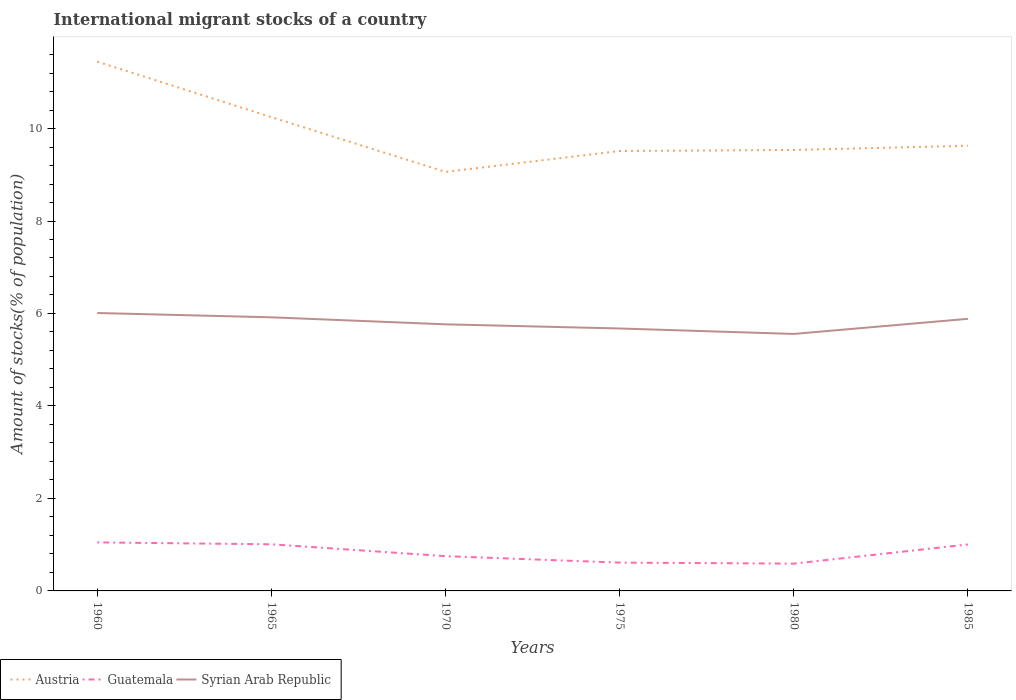Does the line corresponding to Guatemala intersect with the line corresponding to Austria?
Give a very brief answer. No. Is the number of lines equal to the number of legend labels?
Provide a succinct answer. Yes. Across all years, what is the maximum amount of stocks in in Austria?
Your answer should be very brief. 9.06. In which year was the amount of stocks in in Guatemala maximum?
Offer a terse response. 1980. What is the total amount of stocks in in Guatemala in the graph?
Make the answer very short. 0.16. What is the difference between the highest and the second highest amount of stocks in in Syrian Arab Republic?
Your answer should be very brief. 0.45. What is the difference between the highest and the lowest amount of stocks in in Guatemala?
Your answer should be very brief. 3. How many lines are there?
Offer a very short reply. 3. What is the title of the graph?
Give a very brief answer. International migrant stocks of a country. Does "Greenland" appear as one of the legend labels in the graph?
Ensure brevity in your answer.  No. What is the label or title of the X-axis?
Offer a terse response. Years. What is the label or title of the Y-axis?
Ensure brevity in your answer.  Amount of stocks(% of population). What is the Amount of stocks(% of population) in Austria in 1960?
Make the answer very short. 11.45. What is the Amount of stocks(% of population) in Guatemala in 1960?
Offer a very short reply. 1.05. What is the Amount of stocks(% of population) of Syrian Arab Republic in 1960?
Offer a very short reply. 6.01. What is the Amount of stocks(% of population) of Austria in 1965?
Your answer should be compact. 10.25. What is the Amount of stocks(% of population) in Guatemala in 1965?
Offer a terse response. 1.01. What is the Amount of stocks(% of population) in Syrian Arab Republic in 1965?
Keep it short and to the point. 5.92. What is the Amount of stocks(% of population) in Austria in 1970?
Give a very brief answer. 9.06. What is the Amount of stocks(% of population) of Guatemala in 1970?
Your answer should be very brief. 0.75. What is the Amount of stocks(% of population) in Syrian Arab Republic in 1970?
Your answer should be very brief. 5.77. What is the Amount of stocks(% of population) of Austria in 1975?
Your answer should be very brief. 9.51. What is the Amount of stocks(% of population) of Guatemala in 1975?
Give a very brief answer. 0.61. What is the Amount of stocks(% of population) of Syrian Arab Republic in 1975?
Offer a terse response. 5.68. What is the Amount of stocks(% of population) of Austria in 1980?
Give a very brief answer. 9.54. What is the Amount of stocks(% of population) in Guatemala in 1980?
Your answer should be very brief. 0.59. What is the Amount of stocks(% of population) in Syrian Arab Republic in 1980?
Provide a short and direct response. 5.56. What is the Amount of stocks(% of population) of Austria in 1985?
Provide a succinct answer. 9.63. What is the Amount of stocks(% of population) of Guatemala in 1985?
Ensure brevity in your answer.  1.01. What is the Amount of stocks(% of population) in Syrian Arab Republic in 1985?
Make the answer very short. 5.88. Across all years, what is the maximum Amount of stocks(% of population) of Austria?
Provide a short and direct response. 11.45. Across all years, what is the maximum Amount of stocks(% of population) in Guatemala?
Your answer should be very brief. 1.05. Across all years, what is the maximum Amount of stocks(% of population) of Syrian Arab Republic?
Provide a short and direct response. 6.01. Across all years, what is the minimum Amount of stocks(% of population) of Austria?
Your answer should be very brief. 9.06. Across all years, what is the minimum Amount of stocks(% of population) of Guatemala?
Your response must be concise. 0.59. Across all years, what is the minimum Amount of stocks(% of population) of Syrian Arab Republic?
Give a very brief answer. 5.56. What is the total Amount of stocks(% of population) in Austria in the graph?
Give a very brief answer. 59.43. What is the total Amount of stocks(% of population) of Guatemala in the graph?
Ensure brevity in your answer.  5.02. What is the total Amount of stocks(% of population) of Syrian Arab Republic in the graph?
Keep it short and to the point. 34.81. What is the difference between the Amount of stocks(% of population) of Austria in 1960 and that in 1965?
Offer a very short reply. 1.2. What is the difference between the Amount of stocks(% of population) of Guatemala in 1960 and that in 1965?
Keep it short and to the point. 0.04. What is the difference between the Amount of stocks(% of population) of Syrian Arab Republic in 1960 and that in 1965?
Your answer should be compact. 0.09. What is the difference between the Amount of stocks(% of population) of Austria in 1960 and that in 1970?
Make the answer very short. 2.38. What is the difference between the Amount of stocks(% of population) in Guatemala in 1960 and that in 1970?
Make the answer very short. 0.3. What is the difference between the Amount of stocks(% of population) of Syrian Arab Republic in 1960 and that in 1970?
Give a very brief answer. 0.25. What is the difference between the Amount of stocks(% of population) in Austria in 1960 and that in 1975?
Give a very brief answer. 1.93. What is the difference between the Amount of stocks(% of population) in Guatemala in 1960 and that in 1975?
Provide a short and direct response. 0.44. What is the difference between the Amount of stocks(% of population) of Syrian Arab Republic in 1960 and that in 1975?
Offer a terse response. 0.34. What is the difference between the Amount of stocks(% of population) of Austria in 1960 and that in 1980?
Offer a terse response. 1.91. What is the difference between the Amount of stocks(% of population) of Guatemala in 1960 and that in 1980?
Make the answer very short. 0.46. What is the difference between the Amount of stocks(% of population) in Syrian Arab Republic in 1960 and that in 1980?
Give a very brief answer. 0.45. What is the difference between the Amount of stocks(% of population) in Austria in 1960 and that in 1985?
Offer a terse response. 1.82. What is the difference between the Amount of stocks(% of population) in Guatemala in 1960 and that in 1985?
Your answer should be compact. 0.04. What is the difference between the Amount of stocks(% of population) of Syrian Arab Republic in 1960 and that in 1985?
Offer a very short reply. 0.13. What is the difference between the Amount of stocks(% of population) in Austria in 1965 and that in 1970?
Give a very brief answer. 1.18. What is the difference between the Amount of stocks(% of population) in Guatemala in 1965 and that in 1970?
Offer a terse response. 0.26. What is the difference between the Amount of stocks(% of population) in Syrian Arab Republic in 1965 and that in 1970?
Keep it short and to the point. 0.15. What is the difference between the Amount of stocks(% of population) in Austria in 1965 and that in 1975?
Offer a terse response. 0.73. What is the difference between the Amount of stocks(% of population) of Guatemala in 1965 and that in 1975?
Your answer should be very brief. 0.4. What is the difference between the Amount of stocks(% of population) of Syrian Arab Republic in 1965 and that in 1975?
Offer a terse response. 0.24. What is the difference between the Amount of stocks(% of population) of Austria in 1965 and that in 1980?
Your response must be concise. 0.71. What is the difference between the Amount of stocks(% of population) in Guatemala in 1965 and that in 1980?
Provide a short and direct response. 0.42. What is the difference between the Amount of stocks(% of population) of Syrian Arab Republic in 1965 and that in 1980?
Give a very brief answer. 0.36. What is the difference between the Amount of stocks(% of population) of Austria in 1965 and that in 1985?
Offer a very short reply. 0.62. What is the difference between the Amount of stocks(% of population) in Guatemala in 1965 and that in 1985?
Give a very brief answer. 0. What is the difference between the Amount of stocks(% of population) of Syrian Arab Republic in 1965 and that in 1985?
Offer a terse response. 0.03. What is the difference between the Amount of stocks(% of population) of Austria in 1970 and that in 1975?
Give a very brief answer. -0.45. What is the difference between the Amount of stocks(% of population) in Guatemala in 1970 and that in 1975?
Your response must be concise. 0.14. What is the difference between the Amount of stocks(% of population) in Syrian Arab Republic in 1970 and that in 1975?
Give a very brief answer. 0.09. What is the difference between the Amount of stocks(% of population) in Austria in 1970 and that in 1980?
Offer a very short reply. -0.47. What is the difference between the Amount of stocks(% of population) of Guatemala in 1970 and that in 1980?
Provide a short and direct response. 0.16. What is the difference between the Amount of stocks(% of population) in Syrian Arab Republic in 1970 and that in 1980?
Your answer should be very brief. 0.21. What is the difference between the Amount of stocks(% of population) in Austria in 1970 and that in 1985?
Ensure brevity in your answer.  -0.57. What is the difference between the Amount of stocks(% of population) of Guatemala in 1970 and that in 1985?
Provide a short and direct response. -0.25. What is the difference between the Amount of stocks(% of population) in Syrian Arab Republic in 1970 and that in 1985?
Your answer should be compact. -0.12. What is the difference between the Amount of stocks(% of population) in Austria in 1975 and that in 1980?
Make the answer very short. -0.02. What is the difference between the Amount of stocks(% of population) in Guatemala in 1975 and that in 1980?
Provide a short and direct response. 0.02. What is the difference between the Amount of stocks(% of population) of Syrian Arab Republic in 1975 and that in 1980?
Keep it short and to the point. 0.12. What is the difference between the Amount of stocks(% of population) of Austria in 1975 and that in 1985?
Provide a succinct answer. -0.11. What is the difference between the Amount of stocks(% of population) of Guatemala in 1975 and that in 1985?
Keep it short and to the point. -0.39. What is the difference between the Amount of stocks(% of population) of Syrian Arab Republic in 1975 and that in 1985?
Offer a terse response. -0.21. What is the difference between the Amount of stocks(% of population) of Austria in 1980 and that in 1985?
Your answer should be compact. -0.09. What is the difference between the Amount of stocks(% of population) in Guatemala in 1980 and that in 1985?
Provide a succinct answer. -0.41. What is the difference between the Amount of stocks(% of population) in Syrian Arab Republic in 1980 and that in 1985?
Keep it short and to the point. -0.33. What is the difference between the Amount of stocks(% of population) in Austria in 1960 and the Amount of stocks(% of population) in Guatemala in 1965?
Your answer should be compact. 10.44. What is the difference between the Amount of stocks(% of population) in Austria in 1960 and the Amount of stocks(% of population) in Syrian Arab Republic in 1965?
Offer a terse response. 5.53. What is the difference between the Amount of stocks(% of population) in Guatemala in 1960 and the Amount of stocks(% of population) in Syrian Arab Republic in 1965?
Keep it short and to the point. -4.87. What is the difference between the Amount of stocks(% of population) of Austria in 1960 and the Amount of stocks(% of population) of Guatemala in 1970?
Keep it short and to the point. 10.69. What is the difference between the Amount of stocks(% of population) of Austria in 1960 and the Amount of stocks(% of population) of Syrian Arab Republic in 1970?
Your answer should be compact. 5.68. What is the difference between the Amount of stocks(% of population) of Guatemala in 1960 and the Amount of stocks(% of population) of Syrian Arab Republic in 1970?
Offer a very short reply. -4.72. What is the difference between the Amount of stocks(% of population) in Austria in 1960 and the Amount of stocks(% of population) in Guatemala in 1975?
Make the answer very short. 10.83. What is the difference between the Amount of stocks(% of population) in Austria in 1960 and the Amount of stocks(% of population) in Syrian Arab Republic in 1975?
Give a very brief answer. 5.77. What is the difference between the Amount of stocks(% of population) of Guatemala in 1960 and the Amount of stocks(% of population) of Syrian Arab Republic in 1975?
Offer a very short reply. -4.63. What is the difference between the Amount of stocks(% of population) in Austria in 1960 and the Amount of stocks(% of population) in Guatemala in 1980?
Provide a short and direct response. 10.86. What is the difference between the Amount of stocks(% of population) of Austria in 1960 and the Amount of stocks(% of population) of Syrian Arab Republic in 1980?
Give a very brief answer. 5.89. What is the difference between the Amount of stocks(% of population) of Guatemala in 1960 and the Amount of stocks(% of population) of Syrian Arab Republic in 1980?
Offer a terse response. -4.51. What is the difference between the Amount of stocks(% of population) in Austria in 1960 and the Amount of stocks(% of population) in Guatemala in 1985?
Ensure brevity in your answer.  10.44. What is the difference between the Amount of stocks(% of population) of Austria in 1960 and the Amount of stocks(% of population) of Syrian Arab Republic in 1985?
Ensure brevity in your answer.  5.56. What is the difference between the Amount of stocks(% of population) of Guatemala in 1960 and the Amount of stocks(% of population) of Syrian Arab Republic in 1985?
Offer a terse response. -4.84. What is the difference between the Amount of stocks(% of population) of Austria in 1965 and the Amount of stocks(% of population) of Guatemala in 1970?
Your response must be concise. 9.49. What is the difference between the Amount of stocks(% of population) of Austria in 1965 and the Amount of stocks(% of population) of Syrian Arab Republic in 1970?
Make the answer very short. 4.48. What is the difference between the Amount of stocks(% of population) in Guatemala in 1965 and the Amount of stocks(% of population) in Syrian Arab Republic in 1970?
Give a very brief answer. -4.76. What is the difference between the Amount of stocks(% of population) of Austria in 1965 and the Amount of stocks(% of population) of Guatemala in 1975?
Provide a short and direct response. 9.63. What is the difference between the Amount of stocks(% of population) in Austria in 1965 and the Amount of stocks(% of population) in Syrian Arab Republic in 1975?
Make the answer very short. 4.57. What is the difference between the Amount of stocks(% of population) in Guatemala in 1965 and the Amount of stocks(% of population) in Syrian Arab Republic in 1975?
Make the answer very short. -4.67. What is the difference between the Amount of stocks(% of population) of Austria in 1965 and the Amount of stocks(% of population) of Guatemala in 1980?
Keep it short and to the point. 9.66. What is the difference between the Amount of stocks(% of population) of Austria in 1965 and the Amount of stocks(% of population) of Syrian Arab Republic in 1980?
Give a very brief answer. 4.69. What is the difference between the Amount of stocks(% of population) of Guatemala in 1965 and the Amount of stocks(% of population) of Syrian Arab Republic in 1980?
Offer a terse response. -4.55. What is the difference between the Amount of stocks(% of population) of Austria in 1965 and the Amount of stocks(% of population) of Guatemala in 1985?
Your response must be concise. 9.24. What is the difference between the Amount of stocks(% of population) in Austria in 1965 and the Amount of stocks(% of population) in Syrian Arab Republic in 1985?
Your answer should be compact. 4.36. What is the difference between the Amount of stocks(% of population) of Guatemala in 1965 and the Amount of stocks(% of population) of Syrian Arab Republic in 1985?
Your answer should be very brief. -4.88. What is the difference between the Amount of stocks(% of population) of Austria in 1970 and the Amount of stocks(% of population) of Guatemala in 1975?
Offer a terse response. 8.45. What is the difference between the Amount of stocks(% of population) of Austria in 1970 and the Amount of stocks(% of population) of Syrian Arab Republic in 1975?
Ensure brevity in your answer.  3.39. What is the difference between the Amount of stocks(% of population) of Guatemala in 1970 and the Amount of stocks(% of population) of Syrian Arab Republic in 1975?
Make the answer very short. -4.92. What is the difference between the Amount of stocks(% of population) of Austria in 1970 and the Amount of stocks(% of population) of Guatemala in 1980?
Provide a succinct answer. 8.47. What is the difference between the Amount of stocks(% of population) of Austria in 1970 and the Amount of stocks(% of population) of Syrian Arab Republic in 1980?
Your answer should be compact. 3.5. What is the difference between the Amount of stocks(% of population) in Guatemala in 1970 and the Amount of stocks(% of population) in Syrian Arab Republic in 1980?
Make the answer very short. -4.81. What is the difference between the Amount of stocks(% of population) of Austria in 1970 and the Amount of stocks(% of population) of Guatemala in 1985?
Give a very brief answer. 8.06. What is the difference between the Amount of stocks(% of population) in Austria in 1970 and the Amount of stocks(% of population) in Syrian Arab Republic in 1985?
Keep it short and to the point. 3.18. What is the difference between the Amount of stocks(% of population) in Guatemala in 1970 and the Amount of stocks(% of population) in Syrian Arab Republic in 1985?
Ensure brevity in your answer.  -5.13. What is the difference between the Amount of stocks(% of population) of Austria in 1975 and the Amount of stocks(% of population) of Guatemala in 1980?
Provide a short and direct response. 8.92. What is the difference between the Amount of stocks(% of population) of Austria in 1975 and the Amount of stocks(% of population) of Syrian Arab Republic in 1980?
Make the answer very short. 3.96. What is the difference between the Amount of stocks(% of population) in Guatemala in 1975 and the Amount of stocks(% of population) in Syrian Arab Republic in 1980?
Offer a terse response. -4.95. What is the difference between the Amount of stocks(% of population) of Austria in 1975 and the Amount of stocks(% of population) of Guatemala in 1985?
Keep it short and to the point. 8.51. What is the difference between the Amount of stocks(% of population) in Austria in 1975 and the Amount of stocks(% of population) in Syrian Arab Republic in 1985?
Your answer should be compact. 3.63. What is the difference between the Amount of stocks(% of population) in Guatemala in 1975 and the Amount of stocks(% of population) in Syrian Arab Republic in 1985?
Keep it short and to the point. -5.27. What is the difference between the Amount of stocks(% of population) in Austria in 1980 and the Amount of stocks(% of population) in Guatemala in 1985?
Make the answer very short. 8.53. What is the difference between the Amount of stocks(% of population) in Austria in 1980 and the Amount of stocks(% of population) in Syrian Arab Republic in 1985?
Your answer should be very brief. 3.65. What is the difference between the Amount of stocks(% of population) of Guatemala in 1980 and the Amount of stocks(% of population) of Syrian Arab Republic in 1985?
Ensure brevity in your answer.  -5.29. What is the average Amount of stocks(% of population) of Austria per year?
Offer a very short reply. 9.91. What is the average Amount of stocks(% of population) of Guatemala per year?
Offer a terse response. 0.84. What is the average Amount of stocks(% of population) in Syrian Arab Republic per year?
Offer a very short reply. 5.8. In the year 1960, what is the difference between the Amount of stocks(% of population) in Austria and Amount of stocks(% of population) in Guatemala?
Offer a very short reply. 10.4. In the year 1960, what is the difference between the Amount of stocks(% of population) of Austria and Amount of stocks(% of population) of Syrian Arab Republic?
Make the answer very short. 5.44. In the year 1960, what is the difference between the Amount of stocks(% of population) in Guatemala and Amount of stocks(% of population) in Syrian Arab Republic?
Provide a short and direct response. -4.96. In the year 1965, what is the difference between the Amount of stocks(% of population) in Austria and Amount of stocks(% of population) in Guatemala?
Give a very brief answer. 9.24. In the year 1965, what is the difference between the Amount of stocks(% of population) of Austria and Amount of stocks(% of population) of Syrian Arab Republic?
Keep it short and to the point. 4.33. In the year 1965, what is the difference between the Amount of stocks(% of population) in Guatemala and Amount of stocks(% of population) in Syrian Arab Republic?
Give a very brief answer. -4.91. In the year 1970, what is the difference between the Amount of stocks(% of population) in Austria and Amount of stocks(% of population) in Guatemala?
Keep it short and to the point. 8.31. In the year 1970, what is the difference between the Amount of stocks(% of population) in Austria and Amount of stocks(% of population) in Syrian Arab Republic?
Make the answer very short. 3.3. In the year 1970, what is the difference between the Amount of stocks(% of population) in Guatemala and Amount of stocks(% of population) in Syrian Arab Republic?
Offer a terse response. -5.01. In the year 1975, what is the difference between the Amount of stocks(% of population) of Austria and Amount of stocks(% of population) of Guatemala?
Offer a terse response. 8.9. In the year 1975, what is the difference between the Amount of stocks(% of population) of Austria and Amount of stocks(% of population) of Syrian Arab Republic?
Provide a succinct answer. 3.84. In the year 1975, what is the difference between the Amount of stocks(% of population) of Guatemala and Amount of stocks(% of population) of Syrian Arab Republic?
Offer a very short reply. -5.06. In the year 1980, what is the difference between the Amount of stocks(% of population) of Austria and Amount of stocks(% of population) of Guatemala?
Your answer should be very brief. 8.95. In the year 1980, what is the difference between the Amount of stocks(% of population) of Austria and Amount of stocks(% of population) of Syrian Arab Republic?
Give a very brief answer. 3.98. In the year 1980, what is the difference between the Amount of stocks(% of population) in Guatemala and Amount of stocks(% of population) in Syrian Arab Republic?
Your answer should be compact. -4.97. In the year 1985, what is the difference between the Amount of stocks(% of population) of Austria and Amount of stocks(% of population) of Guatemala?
Ensure brevity in your answer.  8.62. In the year 1985, what is the difference between the Amount of stocks(% of population) of Austria and Amount of stocks(% of population) of Syrian Arab Republic?
Give a very brief answer. 3.74. In the year 1985, what is the difference between the Amount of stocks(% of population) of Guatemala and Amount of stocks(% of population) of Syrian Arab Republic?
Ensure brevity in your answer.  -4.88. What is the ratio of the Amount of stocks(% of population) of Austria in 1960 to that in 1965?
Offer a very short reply. 1.12. What is the ratio of the Amount of stocks(% of population) of Guatemala in 1960 to that in 1965?
Your response must be concise. 1.04. What is the ratio of the Amount of stocks(% of population) in Syrian Arab Republic in 1960 to that in 1965?
Your answer should be compact. 1.02. What is the ratio of the Amount of stocks(% of population) in Austria in 1960 to that in 1970?
Your answer should be compact. 1.26. What is the ratio of the Amount of stocks(% of population) of Guatemala in 1960 to that in 1970?
Provide a succinct answer. 1.4. What is the ratio of the Amount of stocks(% of population) of Syrian Arab Republic in 1960 to that in 1970?
Ensure brevity in your answer.  1.04. What is the ratio of the Amount of stocks(% of population) in Austria in 1960 to that in 1975?
Ensure brevity in your answer.  1.2. What is the ratio of the Amount of stocks(% of population) in Guatemala in 1960 to that in 1975?
Ensure brevity in your answer.  1.71. What is the ratio of the Amount of stocks(% of population) in Syrian Arab Republic in 1960 to that in 1975?
Provide a short and direct response. 1.06. What is the ratio of the Amount of stocks(% of population) of Austria in 1960 to that in 1980?
Your answer should be very brief. 1.2. What is the ratio of the Amount of stocks(% of population) in Guatemala in 1960 to that in 1980?
Provide a short and direct response. 1.78. What is the ratio of the Amount of stocks(% of population) of Syrian Arab Republic in 1960 to that in 1980?
Your response must be concise. 1.08. What is the ratio of the Amount of stocks(% of population) of Austria in 1960 to that in 1985?
Keep it short and to the point. 1.19. What is the ratio of the Amount of stocks(% of population) of Guatemala in 1960 to that in 1985?
Give a very brief answer. 1.04. What is the ratio of the Amount of stocks(% of population) of Syrian Arab Republic in 1960 to that in 1985?
Provide a short and direct response. 1.02. What is the ratio of the Amount of stocks(% of population) in Austria in 1965 to that in 1970?
Give a very brief answer. 1.13. What is the ratio of the Amount of stocks(% of population) in Guatemala in 1965 to that in 1970?
Offer a terse response. 1.34. What is the ratio of the Amount of stocks(% of population) in Syrian Arab Republic in 1965 to that in 1970?
Offer a terse response. 1.03. What is the ratio of the Amount of stocks(% of population) in Austria in 1965 to that in 1975?
Provide a short and direct response. 1.08. What is the ratio of the Amount of stocks(% of population) of Guatemala in 1965 to that in 1975?
Provide a short and direct response. 1.65. What is the ratio of the Amount of stocks(% of population) in Syrian Arab Republic in 1965 to that in 1975?
Provide a succinct answer. 1.04. What is the ratio of the Amount of stocks(% of population) of Austria in 1965 to that in 1980?
Make the answer very short. 1.07. What is the ratio of the Amount of stocks(% of population) of Guatemala in 1965 to that in 1980?
Ensure brevity in your answer.  1.71. What is the ratio of the Amount of stocks(% of population) in Syrian Arab Republic in 1965 to that in 1980?
Offer a terse response. 1.06. What is the ratio of the Amount of stocks(% of population) of Austria in 1965 to that in 1985?
Provide a short and direct response. 1.06. What is the ratio of the Amount of stocks(% of population) of Syrian Arab Republic in 1965 to that in 1985?
Your answer should be compact. 1.01. What is the ratio of the Amount of stocks(% of population) in Austria in 1970 to that in 1975?
Make the answer very short. 0.95. What is the ratio of the Amount of stocks(% of population) of Guatemala in 1970 to that in 1975?
Offer a very short reply. 1.23. What is the ratio of the Amount of stocks(% of population) of Syrian Arab Republic in 1970 to that in 1975?
Keep it short and to the point. 1.02. What is the ratio of the Amount of stocks(% of population) in Austria in 1970 to that in 1980?
Keep it short and to the point. 0.95. What is the ratio of the Amount of stocks(% of population) in Guatemala in 1970 to that in 1980?
Your answer should be compact. 1.27. What is the ratio of the Amount of stocks(% of population) in Syrian Arab Republic in 1970 to that in 1980?
Offer a very short reply. 1.04. What is the ratio of the Amount of stocks(% of population) in Austria in 1970 to that in 1985?
Ensure brevity in your answer.  0.94. What is the ratio of the Amount of stocks(% of population) of Guatemala in 1970 to that in 1985?
Provide a short and direct response. 0.75. What is the ratio of the Amount of stocks(% of population) in Syrian Arab Republic in 1970 to that in 1985?
Your answer should be very brief. 0.98. What is the ratio of the Amount of stocks(% of population) of Austria in 1975 to that in 1980?
Your answer should be compact. 1. What is the ratio of the Amount of stocks(% of population) of Guatemala in 1975 to that in 1980?
Keep it short and to the point. 1.04. What is the ratio of the Amount of stocks(% of population) of Syrian Arab Republic in 1975 to that in 1980?
Your response must be concise. 1.02. What is the ratio of the Amount of stocks(% of population) of Austria in 1975 to that in 1985?
Ensure brevity in your answer.  0.99. What is the ratio of the Amount of stocks(% of population) of Guatemala in 1975 to that in 1985?
Provide a short and direct response. 0.61. What is the ratio of the Amount of stocks(% of population) in Syrian Arab Republic in 1975 to that in 1985?
Make the answer very short. 0.96. What is the ratio of the Amount of stocks(% of population) of Guatemala in 1980 to that in 1985?
Provide a succinct answer. 0.59. What is the ratio of the Amount of stocks(% of population) in Syrian Arab Republic in 1980 to that in 1985?
Your response must be concise. 0.94. What is the difference between the highest and the second highest Amount of stocks(% of population) of Austria?
Your answer should be compact. 1.2. What is the difference between the highest and the second highest Amount of stocks(% of population) of Guatemala?
Your answer should be very brief. 0.04. What is the difference between the highest and the second highest Amount of stocks(% of population) in Syrian Arab Republic?
Your response must be concise. 0.09. What is the difference between the highest and the lowest Amount of stocks(% of population) in Austria?
Keep it short and to the point. 2.38. What is the difference between the highest and the lowest Amount of stocks(% of population) in Guatemala?
Offer a terse response. 0.46. What is the difference between the highest and the lowest Amount of stocks(% of population) of Syrian Arab Republic?
Your response must be concise. 0.45. 